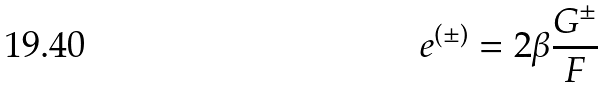Convert formula to latex. <formula><loc_0><loc_0><loc_500><loc_500>e ^ { ( \pm ) } = 2 \beta \frac { G ^ { \pm } } { F }</formula> 